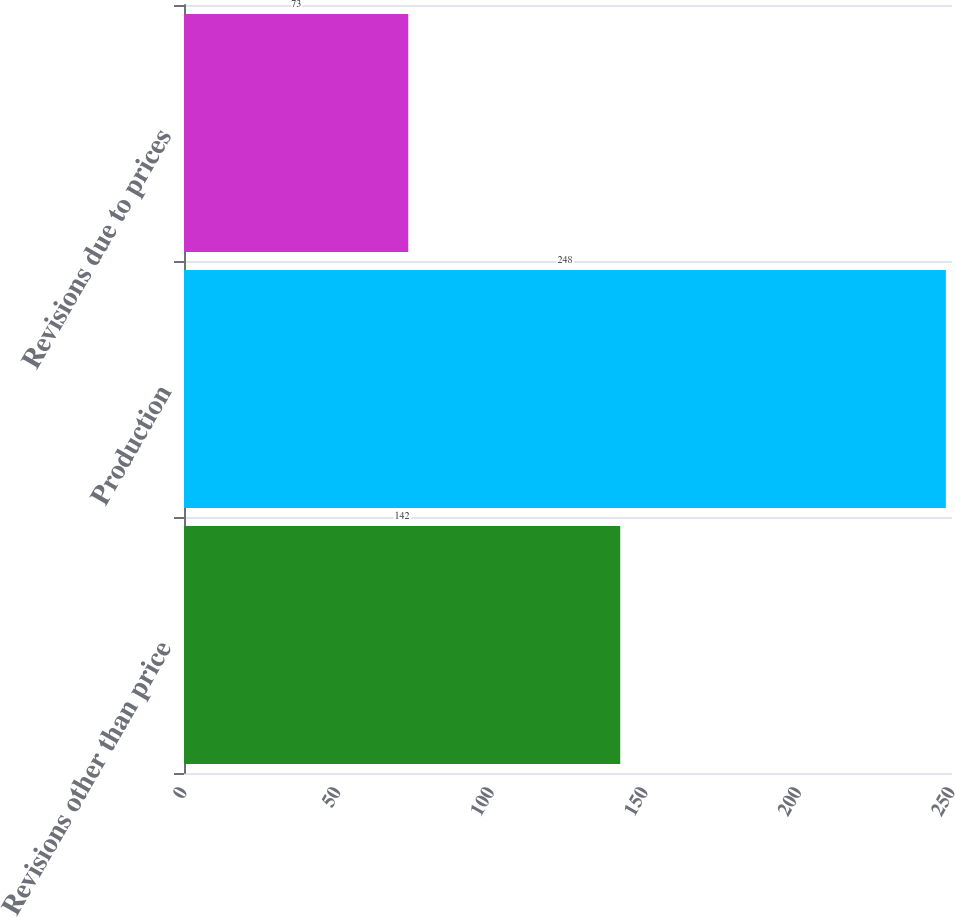<chart> <loc_0><loc_0><loc_500><loc_500><bar_chart><fcel>Revisions other than price<fcel>Production<fcel>Revisions due to prices<nl><fcel>142<fcel>248<fcel>73<nl></chart> 